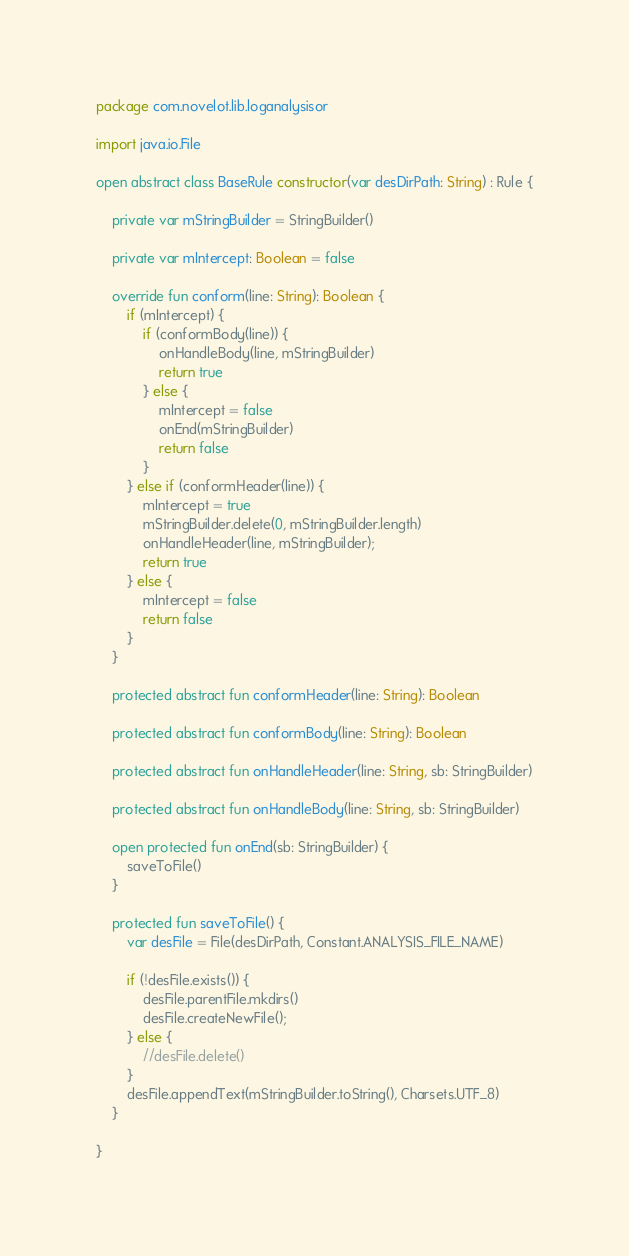<code> <loc_0><loc_0><loc_500><loc_500><_Kotlin_>package com.novelot.lib.loganalysisor

import java.io.File

open abstract class BaseRule constructor(var desDirPath: String) : Rule {

    private var mStringBuilder = StringBuilder()

    private var mIntercept: Boolean = false

    override fun conform(line: String): Boolean {
        if (mIntercept) {
            if (conformBody(line)) {
                onHandleBody(line, mStringBuilder)
                return true
            } else {
                mIntercept = false
                onEnd(mStringBuilder)
                return false
            }
        } else if (conformHeader(line)) {
            mIntercept = true
            mStringBuilder.delete(0, mStringBuilder.length)
            onHandleHeader(line, mStringBuilder);
            return true
        } else {
            mIntercept = false
            return false
        }
    }

    protected abstract fun conformHeader(line: String): Boolean

    protected abstract fun conformBody(line: String): Boolean

    protected abstract fun onHandleHeader(line: String, sb: StringBuilder)

    protected abstract fun onHandleBody(line: String, sb: StringBuilder)

    open protected fun onEnd(sb: StringBuilder) {
        saveToFile()
    }

    protected fun saveToFile() {
        var desFile = File(desDirPath, Constant.ANALYSIS_FILE_NAME)

        if (!desFile.exists()) {
            desFile.parentFile.mkdirs()
            desFile.createNewFile();
        } else {
            //desFile.delete()
        }
        desFile.appendText(mStringBuilder.toString(), Charsets.UTF_8)
    }

}</code> 